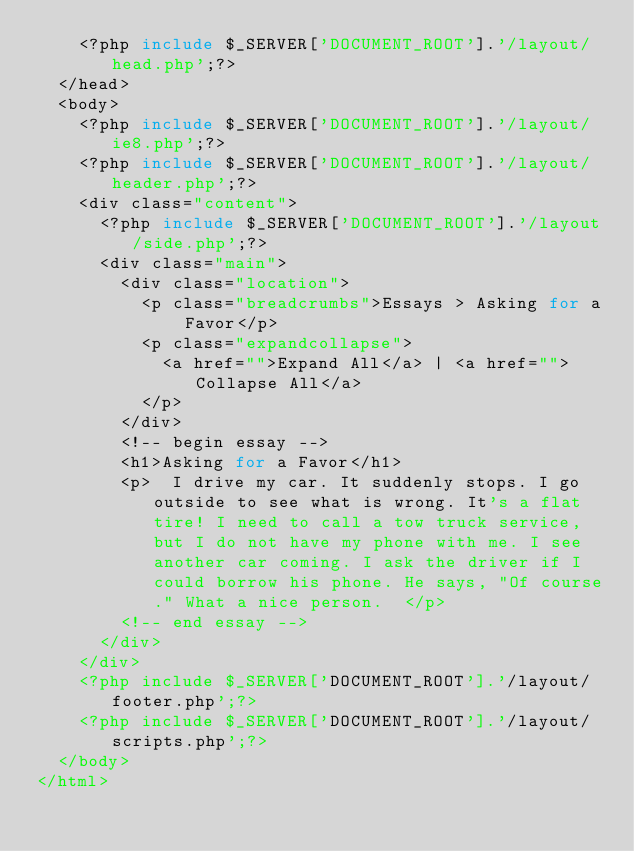<code> <loc_0><loc_0><loc_500><loc_500><_PHP_>		<?php include $_SERVER['DOCUMENT_ROOT'].'/layout/head.php';?>
	</head>
	<body>
		<?php include $_SERVER['DOCUMENT_ROOT'].'/layout/ie8.php';?>
		<?php include $_SERVER['DOCUMENT_ROOT'].'/layout/header.php';?>
		<div class="content">
			<?php include $_SERVER['DOCUMENT_ROOT'].'/layout/side.php';?>
			<div class="main">
				<div class="location">
					<p class="breadcrumbs">Essays > Asking for a Favor</p>
					<p class="expandcollapse">
						<a href="">Expand All</a> | <a href="">Collapse All</a>
					</p>
				</div>
				<!-- begin essay -->
				<h1>Asking for a Favor</h1>
				<p>  I drive my car. It suddenly stops. I go outside to see what is wrong. It's a flat tire! I need to call a tow truck service, but I do not have my phone with me. I see another car coming. I ask the driver if I could borrow his phone. He says, "Of course." What a nice person.  </p>
				<!-- end essay -->
			</div>
		</div>
		<?php include $_SERVER['DOCUMENT_ROOT'].'/layout/footer.php';?>
		<?php include $_SERVER['DOCUMENT_ROOT'].'/layout/scripts.php';?>
	</body>
</html></code> 